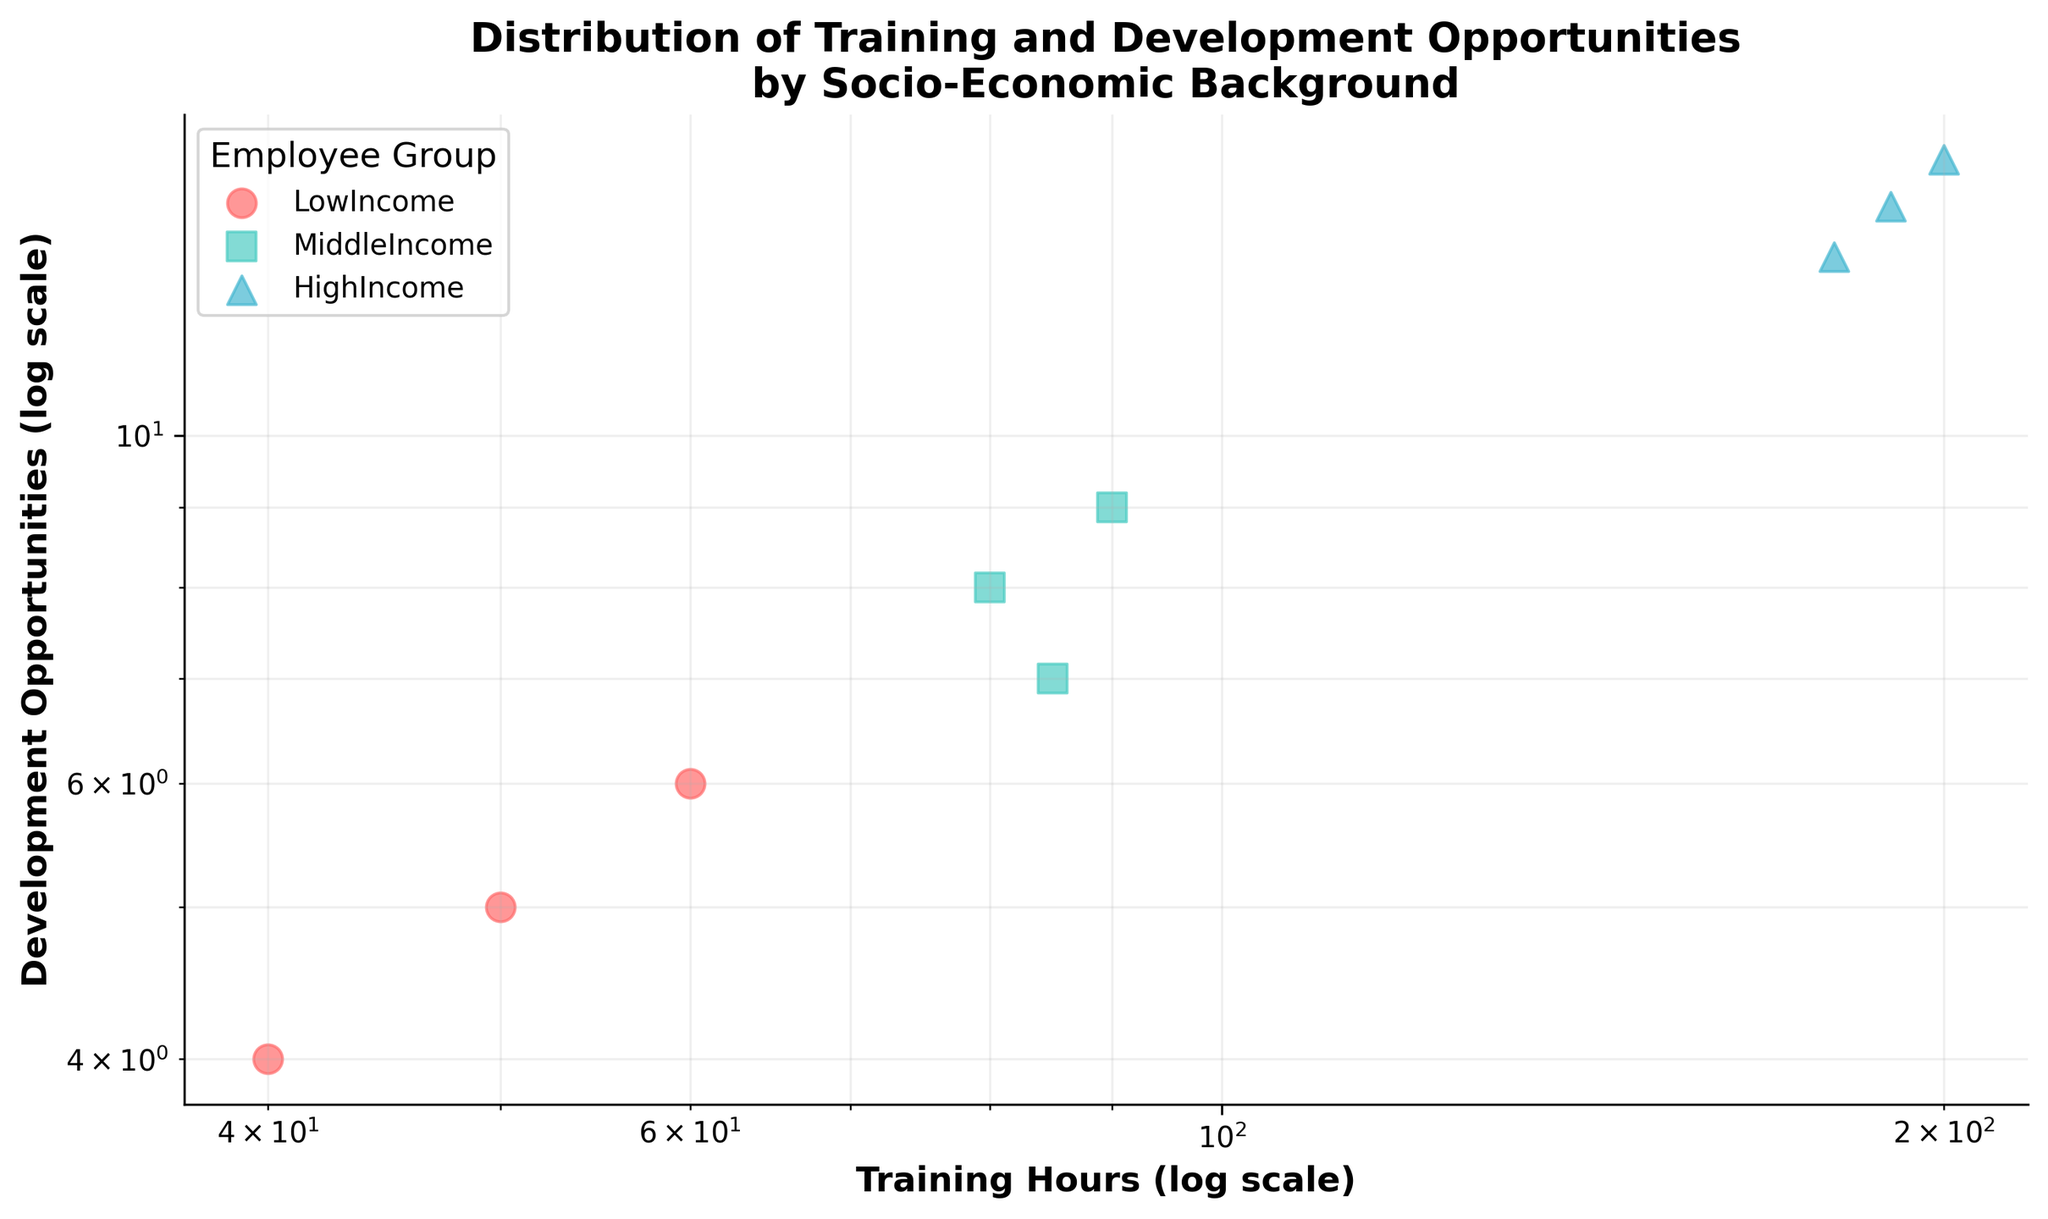What does the title of the figure say? The title of the figure is at the top of the plot, and it summarizes the content it presents. It states: "Distribution of Training and Development Opportunities by Socio-Economic Background."
Answer: Distribution of Training and Development Opportunities by Socio-Economic Background How many data points are there for each employee group? By counting the number of markers for each color/shape combination, we can determine the number of data points for each group. There are 3 for LowIncome, 3 for MiddleIncome, and 3 for HighIncome.
Answer: 3 for each group Which group has the highest average number of training hours? To find the average number of training hours for each group, sum the training hours within each group and then divide by the number of data points. The averages are: LowIncome (50+40+60)/3 = 50, MiddleIncome (80+90+85)/3 = 85, HighIncome (200+180+190)/3 = 190. HighIncome has the highest average.
Answer: HighIncome Which employee group has more development opportunities for a given amount of training hours? Observing the scatter plot, the markers for HighIncome (marked with ^) are positioned higher on the y-axis (Development Opportunities) compared to the others for a given range on the x-axis (Training Hours).
Answer: HighIncome What is the relationship between training hours and development opportunities for LowIncome employees? The markers for LowIncome are placed approximately linearly on the log-log scale plot, suggesting a proportional relationship. As training hours increase, development opportunities increase similarly for LowIncome employees.
Answer: Proportional Which socio-economic group appears to have the least variation in their training hours? Observing the horizontal spread of data points, the LowIncome group shows the least variation in their training hours as the points are close to each other horizontally compared to MiddleIncome and HighIncome groups.
Answer: LowIncome What pattern can be observed in the plot using the log scale for both axes? On a log-log scale, a linear pattern would suggest an exponential relationship in the original scale. The plot for each group shows a roughly linear pattern indicating training hours and development opportunities are exponentially related.
Answer: Exponential relationship What is the color used for the MiddleIncome group? The color used to represent the MiddleIncome group can be identified in the legend and by the markers on the scatter plot. The MiddleIncome group is depicted in teal green.
Answer: Teal green Which income group has the most consistent ratio of training hours to development opportunities? The consistency in ratio can be observed by the alignment of the data points along a line on the log-log scale. The HighIncome group shows a consistent ratio as their data points form a tight linear cluster.
Answer: HighIncome If an employee from the HighIncome group has 190 training hours, how many development opportunities do they likely have? By locating the point for the HighIncome group (marked with ^) near 190 training hours on the plot, the corresponding y-axis value shows around 14 development opportunities.
Answer: 14 